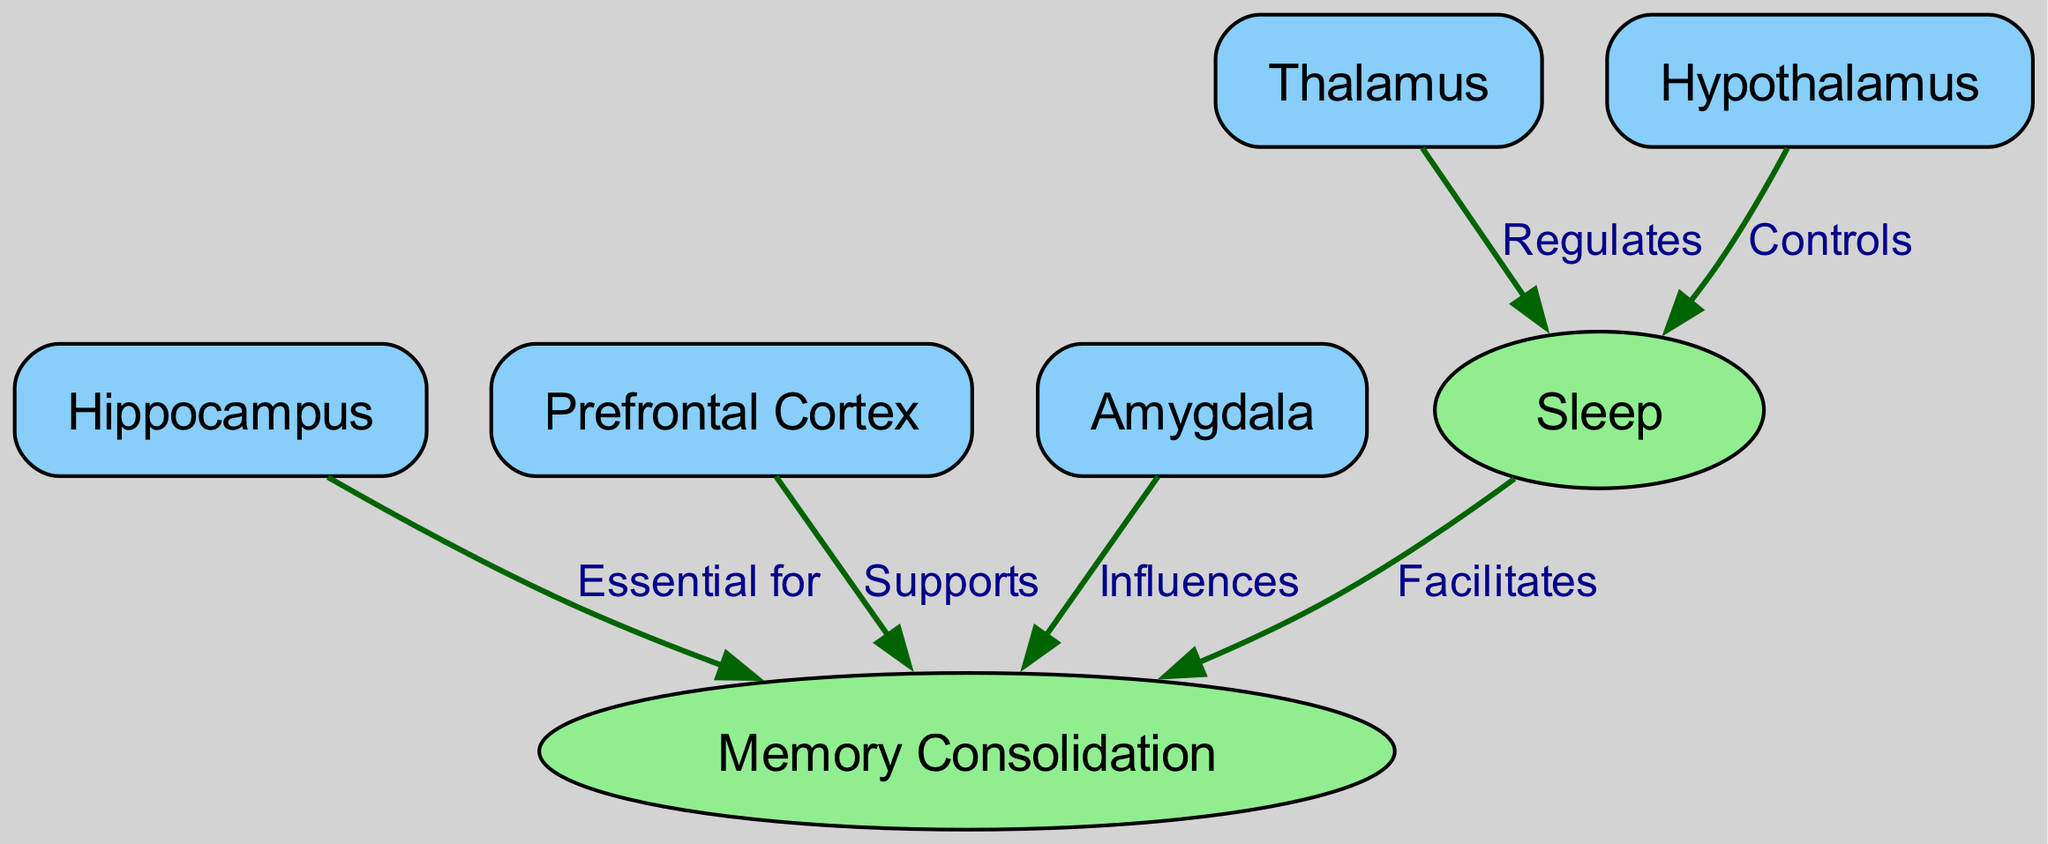What are the three main structures illustrated that are involved in memory? The diagram includes the Hippocampus, Prefrontal Cortex, and Amygdala, all of which are represented as nodes connected to Memory Consolidation.
Answer: Hippocampus, Prefrontal Cortex, Amygdala How many nodes are present in the diagram? Counting the nodes listed in the diagram, we identify seven distinct entities: Hippocampus, Prefrontal Cortex, Amygdala, Thalamus, Hypothalamus, Sleep, and Memory Consolidation.
Answer: 7 What does the Thalamus do in relation to sleep? The Thalamus is labeled in the diagram as "Regulates" Sleep, indicating its role in managing sleep states.
Answer: Regulates Which structure is essential for Memory Consolidation? The diagram explicitly states that the Hippocampus is "Essential for" Memory Consolidation, highlighting its critical role in this function.
Answer: Hippocampus What is the relationship between Sleep and Memory Consolidation? The diagram shows an arrow labeled "Facilitates" that connects Sleep to Memory Consolidation, indicating that Sleep helps in the process of consolidating memories.
Answer: Facilitates How does the Hypothalamus interact with Sleep? The diagram shows that the Hypothalamus "Controls" Sleep, indicating its function in the regulation of sleep patterns and states.
Answer: Controls What is the influence of the Amygdala on memory? The relationship shown in the diagram indicates that the Amygdala "Influences" Memory Consolidation, suggesting its role in emotional memories.
Answer: Influences Which two structures are primarily linked to regulating sleep? The diagram depicts both the Thalamus and the Hypothalamus as having direct control and regulation over Sleep, showing their mutual importance in sleep management.
Answer: Thalamus, Hypothalamus Which node acts as a facilitator between Sleep and Memory Consolidation? The diagram illustrates that Sleep has an arrow leading to Memory Consolidation labeled "Facilitates," showing its supportive role in this process.
Answer: Sleep 